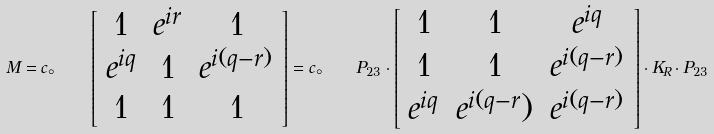Convert formula to latex. <formula><loc_0><loc_0><loc_500><loc_500>M = c _ { \circ } \quad \left [ \begin{array} { c c c } 1 & e ^ { i r } & 1 \\ e ^ { i q } & 1 & e ^ { i ( q - r ) } \\ 1 & 1 & 1 \end{array} \right ] = c _ { \circ } \quad P _ { 2 3 } \cdot \left [ \begin{array} { c c c } 1 & 1 & e ^ { i q } \\ 1 & 1 & e ^ { i ( q - r ) } \\ e ^ { i q } & e ^ { i ( q - r } ) & e ^ { i ( q - r ) } \end{array} \right ] \cdot K _ { R } \cdot P _ { 2 3 }</formula> 